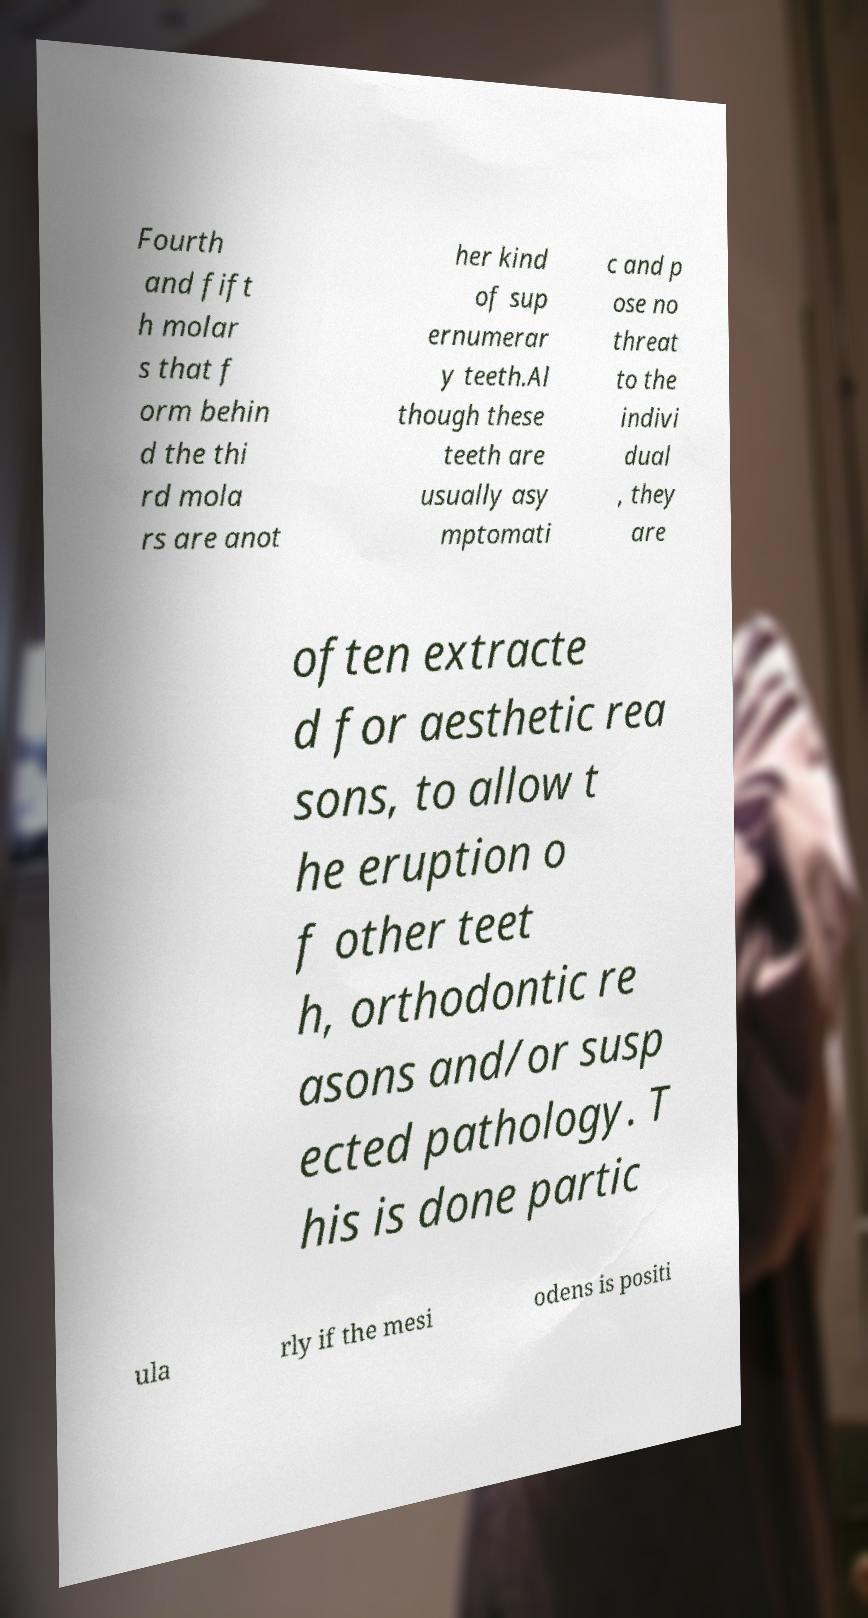There's text embedded in this image that I need extracted. Can you transcribe it verbatim? Fourth and fift h molar s that f orm behin d the thi rd mola rs are anot her kind of sup ernumerar y teeth.Al though these teeth are usually asy mptomati c and p ose no threat to the indivi dual , they are often extracte d for aesthetic rea sons, to allow t he eruption o f other teet h, orthodontic re asons and/or susp ected pathology. T his is done partic ula rly if the mesi odens is positi 